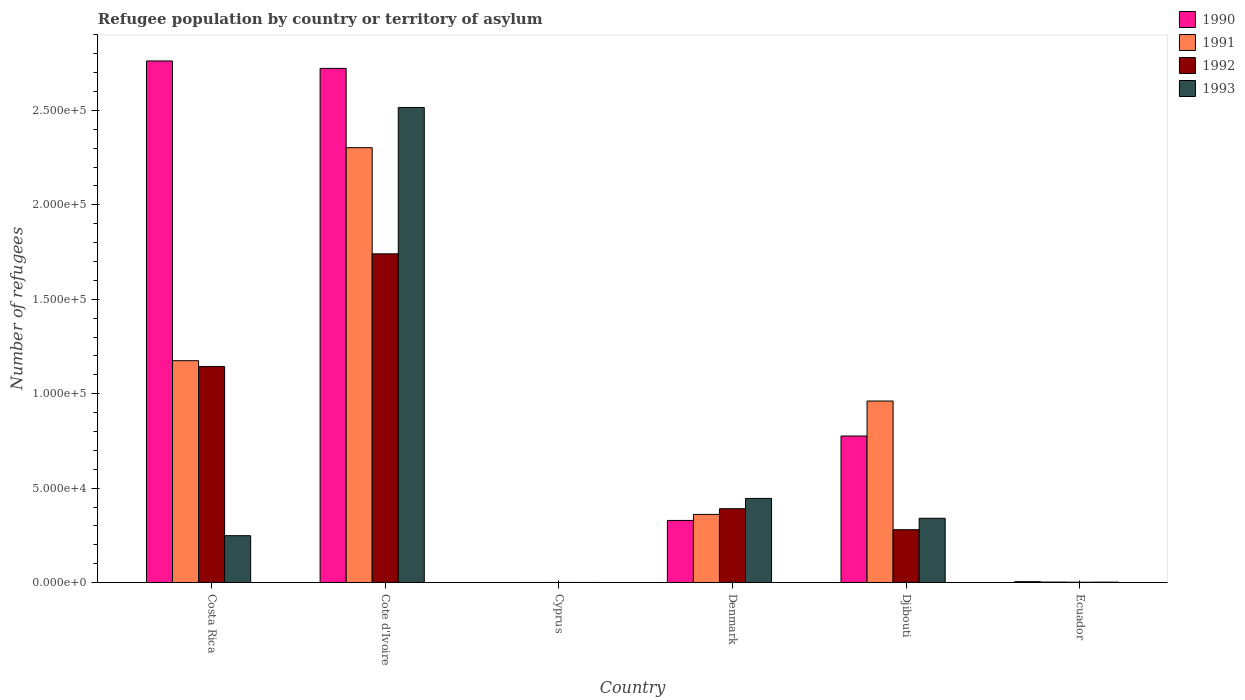How many different coloured bars are there?
Your response must be concise. 4. How many groups of bars are there?
Your response must be concise. 6. How many bars are there on the 3rd tick from the left?
Keep it short and to the point. 4. How many bars are there on the 4th tick from the right?
Provide a succinct answer. 4. What is the label of the 6th group of bars from the left?
Provide a short and direct response. Ecuador. What is the number of refugees in 1990 in Denmark?
Keep it short and to the point. 3.29e+04. Across all countries, what is the maximum number of refugees in 1992?
Ensure brevity in your answer.  1.74e+05. Across all countries, what is the minimum number of refugees in 1993?
Keep it short and to the point. 82. In which country was the number of refugees in 1993 maximum?
Your response must be concise. Cote d'Ivoire. In which country was the number of refugees in 1990 minimum?
Offer a very short reply. Cyprus. What is the total number of refugees in 1991 in the graph?
Make the answer very short. 4.80e+05. What is the difference between the number of refugees in 1991 in Cyprus and that in Djibouti?
Keep it short and to the point. -9.61e+04. What is the difference between the number of refugees in 1991 in Ecuador and the number of refugees in 1990 in Djibouti?
Your response must be concise. -7.73e+04. What is the average number of refugees in 1993 per country?
Provide a succinct answer. 5.92e+04. What is the difference between the number of refugees of/in 1993 and number of refugees of/in 1990 in Cote d'Ivoire?
Offer a terse response. -2.07e+04. What is the ratio of the number of refugees in 1992 in Costa Rica to that in Djibouti?
Offer a very short reply. 4.09. Is the number of refugees in 1992 in Costa Rica less than that in Djibouti?
Give a very brief answer. No. Is the difference between the number of refugees in 1993 in Denmark and Djibouti greater than the difference between the number of refugees in 1990 in Denmark and Djibouti?
Provide a succinct answer. Yes. What is the difference between the highest and the second highest number of refugees in 1991?
Keep it short and to the point. -1.34e+05. What is the difference between the highest and the lowest number of refugees in 1990?
Make the answer very short. 2.76e+05. What does the 3rd bar from the left in Denmark represents?
Give a very brief answer. 1992. How many bars are there?
Provide a short and direct response. 24. How many countries are there in the graph?
Your answer should be very brief. 6. What is the difference between two consecutive major ticks on the Y-axis?
Your response must be concise. 5.00e+04. Are the values on the major ticks of Y-axis written in scientific E-notation?
Your answer should be very brief. Yes. Does the graph contain grids?
Your answer should be very brief. No. What is the title of the graph?
Your answer should be very brief. Refugee population by country or territory of asylum. What is the label or title of the X-axis?
Your response must be concise. Country. What is the label or title of the Y-axis?
Offer a terse response. Number of refugees. What is the Number of refugees in 1990 in Costa Rica?
Your answer should be very brief. 2.76e+05. What is the Number of refugees of 1991 in Costa Rica?
Offer a terse response. 1.17e+05. What is the Number of refugees in 1992 in Costa Rica?
Give a very brief answer. 1.14e+05. What is the Number of refugees of 1993 in Costa Rica?
Ensure brevity in your answer.  2.48e+04. What is the Number of refugees of 1990 in Cote d'Ivoire?
Offer a terse response. 2.72e+05. What is the Number of refugees of 1991 in Cote d'Ivoire?
Your answer should be very brief. 2.30e+05. What is the Number of refugees of 1992 in Cote d'Ivoire?
Ensure brevity in your answer.  1.74e+05. What is the Number of refugees of 1993 in Cote d'Ivoire?
Your response must be concise. 2.52e+05. What is the Number of refugees of 1991 in Cyprus?
Your answer should be compact. 60. What is the Number of refugees of 1993 in Cyprus?
Offer a terse response. 82. What is the Number of refugees in 1990 in Denmark?
Provide a short and direct response. 3.29e+04. What is the Number of refugees of 1991 in Denmark?
Offer a terse response. 3.61e+04. What is the Number of refugees of 1992 in Denmark?
Your answer should be compact. 3.91e+04. What is the Number of refugees of 1993 in Denmark?
Your response must be concise. 4.46e+04. What is the Number of refugees in 1990 in Djibouti?
Your answer should be compact. 7.76e+04. What is the Number of refugees in 1991 in Djibouti?
Make the answer very short. 9.61e+04. What is the Number of refugees of 1992 in Djibouti?
Your answer should be compact. 2.80e+04. What is the Number of refugees in 1993 in Djibouti?
Your response must be concise. 3.41e+04. What is the Number of refugees in 1990 in Ecuador?
Offer a terse response. 510. What is the Number of refugees in 1991 in Ecuador?
Offer a terse response. 280. What is the Number of refugees in 1992 in Ecuador?
Make the answer very short. 204. What is the Number of refugees of 1993 in Ecuador?
Your answer should be very brief. 238. Across all countries, what is the maximum Number of refugees of 1990?
Keep it short and to the point. 2.76e+05. Across all countries, what is the maximum Number of refugees in 1991?
Give a very brief answer. 2.30e+05. Across all countries, what is the maximum Number of refugees of 1992?
Your answer should be compact. 1.74e+05. Across all countries, what is the maximum Number of refugees of 1993?
Your answer should be compact. 2.52e+05. What is the total Number of refugees in 1990 in the graph?
Give a very brief answer. 6.60e+05. What is the total Number of refugees of 1991 in the graph?
Offer a very short reply. 4.80e+05. What is the total Number of refugees of 1992 in the graph?
Offer a terse response. 3.56e+05. What is the total Number of refugees of 1993 in the graph?
Provide a short and direct response. 3.55e+05. What is the difference between the Number of refugees in 1990 in Costa Rica and that in Cote d'Ivoire?
Give a very brief answer. 3929. What is the difference between the Number of refugees in 1991 in Costa Rica and that in Cote d'Ivoire?
Provide a succinct answer. -1.13e+05. What is the difference between the Number of refugees of 1992 in Costa Rica and that in Cote d'Ivoire?
Offer a terse response. -5.97e+04. What is the difference between the Number of refugees in 1993 in Costa Rica and that in Cote d'Ivoire?
Give a very brief answer. -2.27e+05. What is the difference between the Number of refugees of 1990 in Costa Rica and that in Cyprus?
Provide a succinct answer. 2.76e+05. What is the difference between the Number of refugees of 1991 in Costa Rica and that in Cyprus?
Provide a succinct answer. 1.17e+05. What is the difference between the Number of refugees of 1992 in Costa Rica and that in Cyprus?
Provide a succinct answer. 1.14e+05. What is the difference between the Number of refugees in 1993 in Costa Rica and that in Cyprus?
Make the answer very short. 2.48e+04. What is the difference between the Number of refugees in 1990 in Costa Rica and that in Denmark?
Offer a terse response. 2.43e+05. What is the difference between the Number of refugees of 1991 in Costa Rica and that in Denmark?
Ensure brevity in your answer.  8.14e+04. What is the difference between the Number of refugees in 1992 in Costa Rica and that in Denmark?
Your answer should be compact. 7.53e+04. What is the difference between the Number of refugees in 1993 in Costa Rica and that in Denmark?
Provide a short and direct response. -1.97e+04. What is the difference between the Number of refugees in 1990 in Costa Rica and that in Djibouti?
Your answer should be compact. 1.99e+05. What is the difference between the Number of refugees in 1991 in Costa Rica and that in Djibouti?
Offer a very short reply. 2.13e+04. What is the difference between the Number of refugees of 1992 in Costa Rica and that in Djibouti?
Offer a terse response. 8.64e+04. What is the difference between the Number of refugees of 1993 in Costa Rica and that in Djibouti?
Offer a very short reply. -9231. What is the difference between the Number of refugees of 1990 in Costa Rica and that in Ecuador?
Offer a very short reply. 2.76e+05. What is the difference between the Number of refugees of 1991 in Costa Rica and that in Ecuador?
Provide a short and direct response. 1.17e+05. What is the difference between the Number of refugees in 1992 in Costa Rica and that in Ecuador?
Give a very brief answer. 1.14e+05. What is the difference between the Number of refugees of 1993 in Costa Rica and that in Ecuador?
Keep it short and to the point. 2.46e+04. What is the difference between the Number of refugees of 1990 in Cote d'Ivoire and that in Cyprus?
Offer a terse response. 2.72e+05. What is the difference between the Number of refugees of 1991 in Cote d'Ivoire and that in Cyprus?
Give a very brief answer. 2.30e+05. What is the difference between the Number of refugees in 1992 in Cote d'Ivoire and that in Cyprus?
Make the answer very short. 1.74e+05. What is the difference between the Number of refugees in 1993 in Cote d'Ivoire and that in Cyprus?
Keep it short and to the point. 2.52e+05. What is the difference between the Number of refugees in 1990 in Cote d'Ivoire and that in Denmark?
Ensure brevity in your answer.  2.39e+05. What is the difference between the Number of refugees in 1991 in Cote d'Ivoire and that in Denmark?
Provide a succinct answer. 1.94e+05. What is the difference between the Number of refugees of 1992 in Cote d'Ivoire and that in Denmark?
Your answer should be very brief. 1.35e+05. What is the difference between the Number of refugees in 1993 in Cote d'Ivoire and that in Denmark?
Your answer should be very brief. 2.07e+05. What is the difference between the Number of refugees in 1990 in Cote d'Ivoire and that in Djibouti?
Provide a succinct answer. 1.95e+05. What is the difference between the Number of refugees of 1991 in Cote d'Ivoire and that in Djibouti?
Keep it short and to the point. 1.34e+05. What is the difference between the Number of refugees in 1992 in Cote d'Ivoire and that in Djibouti?
Make the answer very short. 1.46e+05. What is the difference between the Number of refugees of 1993 in Cote d'Ivoire and that in Djibouti?
Provide a short and direct response. 2.18e+05. What is the difference between the Number of refugees in 1990 in Cote d'Ivoire and that in Ecuador?
Make the answer very short. 2.72e+05. What is the difference between the Number of refugees in 1991 in Cote d'Ivoire and that in Ecuador?
Your answer should be compact. 2.30e+05. What is the difference between the Number of refugees in 1992 in Cote d'Ivoire and that in Ecuador?
Offer a terse response. 1.74e+05. What is the difference between the Number of refugees in 1993 in Cote d'Ivoire and that in Ecuador?
Make the answer very short. 2.51e+05. What is the difference between the Number of refugees of 1990 in Cyprus and that in Denmark?
Offer a terse response. -3.29e+04. What is the difference between the Number of refugees of 1991 in Cyprus and that in Denmark?
Offer a very short reply. -3.60e+04. What is the difference between the Number of refugees of 1992 in Cyprus and that in Denmark?
Offer a terse response. -3.90e+04. What is the difference between the Number of refugees of 1993 in Cyprus and that in Denmark?
Provide a succinct answer. -4.45e+04. What is the difference between the Number of refugees in 1990 in Cyprus and that in Djibouti?
Give a very brief answer. -7.76e+04. What is the difference between the Number of refugees of 1991 in Cyprus and that in Djibouti?
Keep it short and to the point. -9.61e+04. What is the difference between the Number of refugees of 1992 in Cyprus and that in Djibouti?
Your answer should be very brief. -2.79e+04. What is the difference between the Number of refugees in 1993 in Cyprus and that in Djibouti?
Ensure brevity in your answer.  -3.40e+04. What is the difference between the Number of refugees in 1990 in Cyprus and that in Ecuador?
Offer a terse response. -477. What is the difference between the Number of refugees in 1991 in Cyprus and that in Ecuador?
Make the answer very short. -220. What is the difference between the Number of refugees in 1992 in Cyprus and that in Ecuador?
Your answer should be very brief. -124. What is the difference between the Number of refugees in 1993 in Cyprus and that in Ecuador?
Offer a terse response. -156. What is the difference between the Number of refugees in 1990 in Denmark and that in Djibouti?
Offer a very short reply. -4.47e+04. What is the difference between the Number of refugees in 1991 in Denmark and that in Djibouti?
Offer a very short reply. -6.00e+04. What is the difference between the Number of refugees of 1992 in Denmark and that in Djibouti?
Your response must be concise. 1.11e+04. What is the difference between the Number of refugees in 1993 in Denmark and that in Djibouti?
Ensure brevity in your answer.  1.05e+04. What is the difference between the Number of refugees in 1990 in Denmark and that in Ecuador?
Give a very brief answer. 3.24e+04. What is the difference between the Number of refugees in 1991 in Denmark and that in Ecuador?
Your answer should be very brief. 3.58e+04. What is the difference between the Number of refugees in 1992 in Denmark and that in Ecuador?
Your answer should be compact. 3.89e+04. What is the difference between the Number of refugees of 1993 in Denmark and that in Ecuador?
Provide a succinct answer. 4.43e+04. What is the difference between the Number of refugees of 1990 in Djibouti and that in Ecuador?
Make the answer very short. 7.71e+04. What is the difference between the Number of refugees in 1991 in Djibouti and that in Ecuador?
Keep it short and to the point. 9.59e+04. What is the difference between the Number of refugees in 1992 in Djibouti and that in Ecuador?
Provide a succinct answer. 2.78e+04. What is the difference between the Number of refugees of 1993 in Djibouti and that in Ecuador?
Give a very brief answer. 3.38e+04. What is the difference between the Number of refugees in 1990 in Costa Rica and the Number of refugees in 1991 in Cote d'Ivoire?
Keep it short and to the point. 4.59e+04. What is the difference between the Number of refugees in 1990 in Costa Rica and the Number of refugees in 1992 in Cote d'Ivoire?
Keep it short and to the point. 1.02e+05. What is the difference between the Number of refugees in 1990 in Costa Rica and the Number of refugees in 1993 in Cote d'Ivoire?
Your response must be concise. 2.46e+04. What is the difference between the Number of refugees in 1991 in Costa Rica and the Number of refugees in 1992 in Cote d'Ivoire?
Offer a very short reply. -5.66e+04. What is the difference between the Number of refugees in 1991 in Costa Rica and the Number of refugees in 1993 in Cote d'Ivoire?
Your response must be concise. -1.34e+05. What is the difference between the Number of refugees of 1992 in Costa Rica and the Number of refugees of 1993 in Cote d'Ivoire?
Your answer should be very brief. -1.37e+05. What is the difference between the Number of refugees in 1990 in Costa Rica and the Number of refugees in 1991 in Cyprus?
Give a very brief answer. 2.76e+05. What is the difference between the Number of refugees in 1990 in Costa Rica and the Number of refugees in 1992 in Cyprus?
Ensure brevity in your answer.  2.76e+05. What is the difference between the Number of refugees of 1990 in Costa Rica and the Number of refugees of 1993 in Cyprus?
Provide a succinct answer. 2.76e+05. What is the difference between the Number of refugees in 1991 in Costa Rica and the Number of refugees in 1992 in Cyprus?
Ensure brevity in your answer.  1.17e+05. What is the difference between the Number of refugees in 1991 in Costa Rica and the Number of refugees in 1993 in Cyprus?
Your response must be concise. 1.17e+05. What is the difference between the Number of refugees in 1992 in Costa Rica and the Number of refugees in 1993 in Cyprus?
Provide a short and direct response. 1.14e+05. What is the difference between the Number of refugees in 1990 in Costa Rica and the Number of refugees in 1991 in Denmark?
Give a very brief answer. 2.40e+05. What is the difference between the Number of refugees of 1990 in Costa Rica and the Number of refugees of 1992 in Denmark?
Offer a very short reply. 2.37e+05. What is the difference between the Number of refugees in 1990 in Costa Rica and the Number of refugees in 1993 in Denmark?
Your answer should be very brief. 2.32e+05. What is the difference between the Number of refugees of 1991 in Costa Rica and the Number of refugees of 1992 in Denmark?
Keep it short and to the point. 7.84e+04. What is the difference between the Number of refugees in 1991 in Costa Rica and the Number of refugees in 1993 in Denmark?
Your response must be concise. 7.29e+04. What is the difference between the Number of refugees in 1992 in Costa Rica and the Number of refugees in 1993 in Denmark?
Ensure brevity in your answer.  6.98e+04. What is the difference between the Number of refugees in 1990 in Costa Rica and the Number of refugees in 1991 in Djibouti?
Your response must be concise. 1.80e+05. What is the difference between the Number of refugees in 1990 in Costa Rica and the Number of refugees in 1992 in Djibouti?
Your answer should be very brief. 2.48e+05. What is the difference between the Number of refugees of 1990 in Costa Rica and the Number of refugees of 1993 in Djibouti?
Provide a short and direct response. 2.42e+05. What is the difference between the Number of refugees of 1991 in Costa Rica and the Number of refugees of 1992 in Djibouti?
Your answer should be compact. 8.95e+04. What is the difference between the Number of refugees in 1991 in Costa Rica and the Number of refugees in 1993 in Djibouti?
Keep it short and to the point. 8.34e+04. What is the difference between the Number of refugees of 1992 in Costa Rica and the Number of refugees of 1993 in Djibouti?
Your response must be concise. 8.03e+04. What is the difference between the Number of refugees of 1990 in Costa Rica and the Number of refugees of 1991 in Ecuador?
Provide a short and direct response. 2.76e+05. What is the difference between the Number of refugees in 1990 in Costa Rica and the Number of refugees in 1992 in Ecuador?
Your answer should be very brief. 2.76e+05. What is the difference between the Number of refugees in 1990 in Costa Rica and the Number of refugees in 1993 in Ecuador?
Make the answer very short. 2.76e+05. What is the difference between the Number of refugees in 1991 in Costa Rica and the Number of refugees in 1992 in Ecuador?
Make the answer very short. 1.17e+05. What is the difference between the Number of refugees in 1991 in Costa Rica and the Number of refugees in 1993 in Ecuador?
Provide a succinct answer. 1.17e+05. What is the difference between the Number of refugees of 1992 in Costa Rica and the Number of refugees of 1993 in Ecuador?
Ensure brevity in your answer.  1.14e+05. What is the difference between the Number of refugees of 1990 in Cote d'Ivoire and the Number of refugees of 1991 in Cyprus?
Ensure brevity in your answer.  2.72e+05. What is the difference between the Number of refugees of 1990 in Cote d'Ivoire and the Number of refugees of 1992 in Cyprus?
Ensure brevity in your answer.  2.72e+05. What is the difference between the Number of refugees of 1990 in Cote d'Ivoire and the Number of refugees of 1993 in Cyprus?
Keep it short and to the point. 2.72e+05. What is the difference between the Number of refugees of 1991 in Cote d'Ivoire and the Number of refugees of 1992 in Cyprus?
Give a very brief answer. 2.30e+05. What is the difference between the Number of refugees in 1991 in Cote d'Ivoire and the Number of refugees in 1993 in Cyprus?
Keep it short and to the point. 2.30e+05. What is the difference between the Number of refugees of 1992 in Cote d'Ivoire and the Number of refugees of 1993 in Cyprus?
Ensure brevity in your answer.  1.74e+05. What is the difference between the Number of refugees of 1990 in Cote d'Ivoire and the Number of refugees of 1991 in Denmark?
Ensure brevity in your answer.  2.36e+05. What is the difference between the Number of refugees of 1990 in Cote d'Ivoire and the Number of refugees of 1992 in Denmark?
Give a very brief answer. 2.33e+05. What is the difference between the Number of refugees in 1990 in Cote d'Ivoire and the Number of refugees in 1993 in Denmark?
Provide a succinct answer. 2.28e+05. What is the difference between the Number of refugees in 1991 in Cote d'Ivoire and the Number of refugees in 1992 in Denmark?
Offer a terse response. 1.91e+05. What is the difference between the Number of refugees in 1991 in Cote d'Ivoire and the Number of refugees in 1993 in Denmark?
Ensure brevity in your answer.  1.86e+05. What is the difference between the Number of refugees in 1992 in Cote d'Ivoire and the Number of refugees in 1993 in Denmark?
Provide a succinct answer. 1.30e+05. What is the difference between the Number of refugees of 1990 in Cote d'Ivoire and the Number of refugees of 1991 in Djibouti?
Make the answer very short. 1.76e+05. What is the difference between the Number of refugees of 1990 in Cote d'Ivoire and the Number of refugees of 1992 in Djibouti?
Make the answer very short. 2.44e+05. What is the difference between the Number of refugees in 1990 in Cote d'Ivoire and the Number of refugees in 1993 in Djibouti?
Offer a very short reply. 2.38e+05. What is the difference between the Number of refugees of 1991 in Cote d'Ivoire and the Number of refugees of 1992 in Djibouti?
Ensure brevity in your answer.  2.02e+05. What is the difference between the Number of refugees in 1991 in Cote d'Ivoire and the Number of refugees in 1993 in Djibouti?
Your response must be concise. 1.96e+05. What is the difference between the Number of refugees in 1992 in Cote d'Ivoire and the Number of refugees in 1993 in Djibouti?
Offer a terse response. 1.40e+05. What is the difference between the Number of refugees in 1990 in Cote d'Ivoire and the Number of refugees in 1991 in Ecuador?
Offer a very short reply. 2.72e+05. What is the difference between the Number of refugees in 1990 in Cote d'Ivoire and the Number of refugees in 1992 in Ecuador?
Provide a short and direct response. 2.72e+05. What is the difference between the Number of refugees in 1990 in Cote d'Ivoire and the Number of refugees in 1993 in Ecuador?
Keep it short and to the point. 2.72e+05. What is the difference between the Number of refugees in 1991 in Cote d'Ivoire and the Number of refugees in 1992 in Ecuador?
Ensure brevity in your answer.  2.30e+05. What is the difference between the Number of refugees in 1991 in Cote d'Ivoire and the Number of refugees in 1993 in Ecuador?
Your response must be concise. 2.30e+05. What is the difference between the Number of refugees in 1992 in Cote d'Ivoire and the Number of refugees in 1993 in Ecuador?
Provide a short and direct response. 1.74e+05. What is the difference between the Number of refugees in 1990 in Cyprus and the Number of refugees in 1991 in Denmark?
Your answer should be compact. -3.61e+04. What is the difference between the Number of refugees of 1990 in Cyprus and the Number of refugees of 1992 in Denmark?
Provide a succinct answer. -3.91e+04. What is the difference between the Number of refugees of 1990 in Cyprus and the Number of refugees of 1993 in Denmark?
Provide a succinct answer. -4.45e+04. What is the difference between the Number of refugees in 1991 in Cyprus and the Number of refugees in 1992 in Denmark?
Provide a short and direct response. -3.91e+04. What is the difference between the Number of refugees of 1991 in Cyprus and the Number of refugees of 1993 in Denmark?
Provide a succinct answer. -4.45e+04. What is the difference between the Number of refugees in 1992 in Cyprus and the Number of refugees in 1993 in Denmark?
Make the answer very short. -4.45e+04. What is the difference between the Number of refugees in 1990 in Cyprus and the Number of refugees in 1991 in Djibouti?
Give a very brief answer. -9.61e+04. What is the difference between the Number of refugees of 1990 in Cyprus and the Number of refugees of 1992 in Djibouti?
Offer a very short reply. -2.80e+04. What is the difference between the Number of refugees of 1990 in Cyprus and the Number of refugees of 1993 in Djibouti?
Provide a short and direct response. -3.40e+04. What is the difference between the Number of refugees of 1991 in Cyprus and the Number of refugees of 1992 in Djibouti?
Give a very brief answer. -2.79e+04. What is the difference between the Number of refugees in 1991 in Cyprus and the Number of refugees in 1993 in Djibouti?
Ensure brevity in your answer.  -3.40e+04. What is the difference between the Number of refugees of 1992 in Cyprus and the Number of refugees of 1993 in Djibouti?
Ensure brevity in your answer.  -3.40e+04. What is the difference between the Number of refugees of 1990 in Cyprus and the Number of refugees of 1991 in Ecuador?
Make the answer very short. -247. What is the difference between the Number of refugees of 1990 in Cyprus and the Number of refugees of 1992 in Ecuador?
Your response must be concise. -171. What is the difference between the Number of refugees in 1990 in Cyprus and the Number of refugees in 1993 in Ecuador?
Ensure brevity in your answer.  -205. What is the difference between the Number of refugees in 1991 in Cyprus and the Number of refugees in 1992 in Ecuador?
Give a very brief answer. -144. What is the difference between the Number of refugees of 1991 in Cyprus and the Number of refugees of 1993 in Ecuador?
Provide a short and direct response. -178. What is the difference between the Number of refugees of 1992 in Cyprus and the Number of refugees of 1993 in Ecuador?
Offer a terse response. -158. What is the difference between the Number of refugees in 1990 in Denmark and the Number of refugees in 1991 in Djibouti?
Provide a succinct answer. -6.32e+04. What is the difference between the Number of refugees in 1990 in Denmark and the Number of refugees in 1992 in Djibouti?
Ensure brevity in your answer.  4906. What is the difference between the Number of refugees of 1990 in Denmark and the Number of refugees of 1993 in Djibouti?
Provide a short and direct response. -1159. What is the difference between the Number of refugees in 1991 in Denmark and the Number of refugees in 1992 in Djibouti?
Keep it short and to the point. 8110. What is the difference between the Number of refugees in 1991 in Denmark and the Number of refugees in 1993 in Djibouti?
Your answer should be very brief. 2045. What is the difference between the Number of refugees in 1992 in Denmark and the Number of refugees in 1993 in Djibouti?
Keep it short and to the point. 5053. What is the difference between the Number of refugees of 1990 in Denmark and the Number of refugees of 1991 in Ecuador?
Offer a very short reply. 3.26e+04. What is the difference between the Number of refugees in 1990 in Denmark and the Number of refugees in 1992 in Ecuador?
Offer a terse response. 3.27e+04. What is the difference between the Number of refugees in 1990 in Denmark and the Number of refugees in 1993 in Ecuador?
Make the answer very short. 3.27e+04. What is the difference between the Number of refugees of 1991 in Denmark and the Number of refugees of 1992 in Ecuador?
Your answer should be very brief. 3.59e+04. What is the difference between the Number of refugees in 1991 in Denmark and the Number of refugees in 1993 in Ecuador?
Give a very brief answer. 3.59e+04. What is the difference between the Number of refugees of 1992 in Denmark and the Number of refugees of 1993 in Ecuador?
Ensure brevity in your answer.  3.89e+04. What is the difference between the Number of refugees of 1990 in Djibouti and the Number of refugees of 1991 in Ecuador?
Make the answer very short. 7.73e+04. What is the difference between the Number of refugees of 1990 in Djibouti and the Number of refugees of 1992 in Ecuador?
Provide a succinct answer. 7.74e+04. What is the difference between the Number of refugees of 1990 in Djibouti and the Number of refugees of 1993 in Ecuador?
Your response must be concise. 7.74e+04. What is the difference between the Number of refugees of 1991 in Djibouti and the Number of refugees of 1992 in Ecuador?
Your response must be concise. 9.59e+04. What is the difference between the Number of refugees in 1991 in Djibouti and the Number of refugees in 1993 in Ecuador?
Ensure brevity in your answer.  9.59e+04. What is the difference between the Number of refugees in 1992 in Djibouti and the Number of refugees in 1993 in Ecuador?
Provide a short and direct response. 2.78e+04. What is the average Number of refugees of 1990 per country?
Keep it short and to the point. 1.10e+05. What is the average Number of refugees in 1991 per country?
Provide a short and direct response. 8.01e+04. What is the average Number of refugees of 1992 per country?
Provide a succinct answer. 5.93e+04. What is the average Number of refugees of 1993 per country?
Ensure brevity in your answer.  5.92e+04. What is the difference between the Number of refugees of 1990 and Number of refugees of 1991 in Costa Rica?
Give a very brief answer. 1.59e+05. What is the difference between the Number of refugees of 1990 and Number of refugees of 1992 in Costa Rica?
Your answer should be compact. 1.62e+05. What is the difference between the Number of refugees of 1990 and Number of refugees of 1993 in Costa Rica?
Provide a succinct answer. 2.51e+05. What is the difference between the Number of refugees in 1991 and Number of refugees in 1992 in Costa Rica?
Your answer should be compact. 3100. What is the difference between the Number of refugees of 1991 and Number of refugees of 1993 in Costa Rica?
Your response must be concise. 9.27e+04. What is the difference between the Number of refugees in 1992 and Number of refugees in 1993 in Costa Rica?
Make the answer very short. 8.96e+04. What is the difference between the Number of refugees of 1990 and Number of refugees of 1991 in Cote d'Ivoire?
Keep it short and to the point. 4.20e+04. What is the difference between the Number of refugees of 1990 and Number of refugees of 1992 in Cote d'Ivoire?
Your response must be concise. 9.82e+04. What is the difference between the Number of refugees in 1990 and Number of refugees in 1993 in Cote d'Ivoire?
Your answer should be compact. 2.07e+04. What is the difference between the Number of refugees in 1991 and Number of refugees in 1992 in Cote d'Ivoire?
Ensure brevity in your answer.  5.62e+04. What is the difference between the Number of refugees in 1991 and Number of refugees in 1993 in Cote d'Ivoire?
Provide a succinct answer. -2.13e+04. What is the difference between the Number of refugees of 1992 and Number of refugees of 1993 in Cote d'Ivoire?
Provide a short and direct response. -7.75e+04. What is the difference between the Number of refugees in 1990 and Number of refugees in 1992 in Cyprus?
Offer a very short reply. -47. What is the difference between the Number of refugees of 1990 and Number of refugees of 1993 in Cyprus?
Give a very brief answer. -49. What is the difference between the Number of refugees of 1991 and Number of refugees of 1993 in Cyprus?
Your answer should be very brief. -22. What is the difference between the Number of refugees of 1990 and Number of refugees of 1991 in Denmark?
Make the answer very short. -3204. What is the difference between the Number of refugees in 1990 and Number of refugees in 1992 in Denmark?
Offer a very short reply. -6212. What is the difference between the Number of refugees in 1990 and Number of refugees in 1993 in Denmark?
Your answer should be very brief. -1.17e+04. What is the difference between the Number of refugees in 1991 and Number of refugees in 1992 in Denmark?
Your answer should be very brief. -3008. What is the difference between the Number of refugees of 1991 and Number of refugees of 1993 in Denmark?
Your answer should be very brief. -8454. What is the difference between the Number of refugees of 1992 and Number of refugees of 1993 in Denmark?
Keep it short and to the point. -5446. What is the difference between the Number of refugees of 1990 and Number of refugees of 1991 in Djibouti?
Make the answer very short. -1.85e+04. What is the difference between the Number of refugees in 1990 and Number of refugees in 1992 in Djibouti?
Ensure brevity in your answer.  4.96e+04. What is the difference between the Number of refugees in 1990 and Number of refugees in 1993 in Djibouti?
Your answer should be compact. 4.35e+04. What is the difference between the Number of refugees of 1991 and Number of refugees of 1992 in Djibouti?
Provide a succinct answer. 6.81e+04. What is the difference between the Number of refugees in 1991 and Number of refugees in 1993 in Djibouti?
Ensure brevity in your answer.  6.21e+04. What is the difference between the Number of refugees of 1992 and Number of refugees of 1993 in Djibouti?
Your answer should be compact. -6065. What is the difference between the Number of refugees of 1990 and Number of refugees of 1991 in Ecuador?
Provide a succinct answer. 230. What is the difference between the Number of refugees in 1990 and Number of refugees in 1992 in Ecuador?
Your answer should be very brief. 306. What is the difference between the Number of refugees of 1990 and Number of refugees of 1993 in Ecuador?
Ensure brevity in your answer.  272. What is the difference between the Number of refugees in 1992 and Number of refugees in 1993 in Ecuador?
Offer a very short reply. -34. What is the ratio of the Number of refugees in 1990 in Costa Rica to that in Cote d'Ivoire?
Offer a terse response. 1.01. What is the ratio of the Number of refugees in 1991 in Costa Rica to that in Cote d'Ivoire?
Keep it short and to the point. 0.51. What is the ratio of the Number of refugees of 1992 in Costa Rica to that in Cote d'Ivoire?
Your response must be concise. 0.66. What is the ratio of the Number of refugees of 1993 in Costa Rica to that in Cote d'Ivoire?
Your response must be concise. 0.1. What is the ratio of the Number of refugees in 1990 in Costa Rica to that in Cyprus?
Offer a terse response. 8370. What is the ratio of the Number of refugees of 1991 in Costa Rica to that in Cyprus?
Keep it short and to the point. 1958.2. What is the ratio of the Number of refugees of 1992 in Costa Rica to that in Cyprus?
Your answer should be very brief. 1429.9. What is the ratio of the Number of refugees in 1993 in Costa Rica to that in Cyprus?
Provide a short and direct response. 302.85. What is the ratio of the Number of refugees in 1990 in Costa Rica to that in Denmark?
Give a very brief answer. 8.39. What is the ratio of the Number of refugees in 1991 in Costa Rica to that in Denmark?
Your answer should be compact. 3.25. What is the ratio of the Number of refugees of 1992 in Costa Rica to that in Denmark?
Provide a short and direct response. 2.92. What is the ratio of the Number of refugees of 1993 in Costa Rica to that in Denmark?
Your response must be concise. 0.56. What is the ratio of the Number of refugees in 1990 in Costa Rica to that in Djibouti?
Ensure brevity in your answer.  3.56. What is the ratio of the Number of refugees of 1991 in Costa Rica to that in Djibouti?
Your answer should be very brief. 1.22. What is the ratio of the Number of refugees of 1992 in Costa Rica to that in Djibouti?
Your answer should be compact. 4.09. What is the ratio of the Number of refugees in 1993 in Costa Rica to that in Djibouti?
Offer a terse response. 0.73. What is the ratio of the Number of refugees in 1990 in Costa Rica to that in Ecuador?
Your response must be concise. 541.59. What is the ratio of the Number of refugees of 1991 in Costa Rica to that in Ecuador?
Provide a succinct answer. 419.61. What is the ratio of the Number of refugees of 1992 in Costa Rica to that in Ecuador?
Provide a succinct answer. 560.75. What is the ratio of the Number of refugees in 1993 in Costa Rica to that in Ecuador?
Make the answer very short. 104.34. What is the ratio of the Number of refugees in 1990 in Cote d'Ivoire to that in Cyprus?
Offer a very short reply. 8250.94. What is the ratio of the Number of refugees of 1991 in Cote d'Ivoire to that in Cyprus?
Provide a succinct answer. 3838.17. What is the ratio of the Number of refugees of 1992 in Cote d'Ivoire to that in Cyprus?
Offer a very short reply. 2175.95. What is the ratio of the Number of refugees of 1993 in Cote d'Ivoire to that in Cyprus?
Your answer should be very brief. 3068.15. What is the ratio of the Number of refugees in 1990 in Cote d'Ivoire to that in Denmark?
Make the answer very short. 8.27. What is the ratio of the Number of refugees of 1991 in Cote d'Ivoire to that in Denmark?
Provide a short and direct response. 6.38. What is the ratio of the Number of refugees of 1992 in Cote d'Ivoire to that in Denmark?
Make the answer very short. 4.45. What is the ratio of the Number of refugees of 1993 in Cote d'Ivoire to that in Denmark?
Offer a very short reply. 5.65. What is the ratio of the Number of refugees of 1990 in Cote d'Ivoire to that in Djibouti?
Provide a short and direct response. 3.51. What is the ratio of the Number of refugees of 1991 in Cote d'Ivoire to that in Djibouti?
Ensure brevity in your answer.  2.4. What is the ratio of the Number of refugees of 1992 in Cote d'Ivoire to that in Djibouti?
Ensure brevity in your answer.  6.22. What is the ratio of the Number of refugees in 1993 in Cote d'Ivoire to that in Djibouti?
Make the answer very short. 7.39. What is the ratio of the Number of refugees in 1990 in Cote d'Ivoire to that in Ecuador?
Offer a terse response. 533.88. What is the ratio of the Number of refugees in 1991 in Cote d'Ivoire to that in Ecuador?
Offer a very short reply. 822.46. What is the ratio of the Number of refugees in 1992 in Cote d'Ivoire to that in Ecuador?
Offer a very short reply. 853.31. What is the ratio of the Number of refugees of 1993 in Cote d'Ivoire to that in Ecuador?
Make the answer very short. 1057.09. What is the ratio of the Number of refugees in 1990 in Cyprus to that in Denmark?
Provide a succinct answer. 0. What is the ratio of the Number of refugees in 1991 in Cyprus to that in Denmark?
Provide a succinct answer. 0. What is the ratio of the Number of refugees in 1992 in Cyprus to that in Denmark?
Your answer should be compact. 0. What is the ratio of the Number of refugees of 1993 in Cyprus to that in Denmark?
Ensure brevity in your answer.  0. What is the ratio of the Number of refugees of 1991 in Cyprus to that in Djibouti?
Keep it short and to the point. 0. What is the ratio of the Number of refugees in 1992 in Cyprus to that in Djibouti?
Your answer should be very brief. 0. What is the ratio of the Number of refugees of 1993 in Cyprus to that in Djibouti?
Your answer should be very brief. 0. What is the ratio of the Number of refugees in 1990 in Cyprus to that in Ecuador?
Offer a terse response. 0.06. What is the ratio of the Number of refugees of 1991 in Cyprus to that in Ecuador?
Offer a terse response. 0.21. What is the ratio of the Number of refugees in 1992 in Cyprus to that in Ecuador?
Your response must be concise. 0.39. What is the ratio of the Number of refugees in 1993 in Cyprus to that in Ecuador?
Offer a very short reply. 0.34. What is the ratio of the Number of refugees of 1990 in Denmark to that in Djibouti?
Offer a terse response. 0.42. What is the ratio of the Number of refugees in 1991 in Denmark to that in Djibouti?
Ensure brevity in your answer.  0.38. What is the ratio of the Number of refugees of 1992 in Denmark to that in Djibouti?
Provide a short and direct response. 1.4. What is the ratio of the Number of refugees of 1993 in Denmark to that in Djibouti?
Keep it short and to the point. 1.31. What is the ratio of the Number of refugees in 1990 in Denmark to that in Ecuador?
Make the answer very short. 64.52. What is the ratio of the Number of refugees of 1991 in Denmark to that in Ecuador?
Offer a very short reply. 128.96. What is the ratio of the Number of refugees in 1992 in Denmark to that in Ecuador?
Offer a very short reply. 191.75. What is the ratio of the Number of refugees of 1993 in Denmark to that in Ecuador?
Offer a terse response. 187.24. What is the ratio of the Number of refugees of 1990 in Djibouti to that in Ecuador?
Offer a terse response. 152.17. What is the ratio of the Number of refugees in 1991 in Djibouti to that in Ecuador?
Offer a very short reply. 343.37. What is the ratio of the Number of refugees in 1992 in Djibouti to that in Ecuador?
Provide a succinct answer. 137.25. What is the ratio of the Number of refugees of 1993 in Djibouti to that in Ecuador?
Provide a short and direct response. 143.13. What is the difference between the highest and the second highest Number of refugees of 1990?
Make the answer very short. 3929. What is the difference between the highest and the second highest Number of refugees of 1991?
Offer a very short reply. 1.13e+05. What is the difference between the highest and the second highest Number of refugees of 1992?
Provide a succinct answer. 5.97e+04. What is the difference between the highest and the second highest Number of refugees of 1993?
Your answer should be compact. 2.07e+05. What is the difference between the highest and the lowest Number of refugees of 1990?
Provide a succinct answer. 2.76e+05. What is the difference between the highest and the lowest Number of refugees in 1991?
Provide a short and direct response. 2.30e+05. What is the difference between the highest and the lowest Number of refugees of 1992?
Ensure brevity in your answer.  1.74e+05. What is the difference between the highest and the lowest Number of refugees in 1993?
Your answer should be very brief. 2.52e+05. 